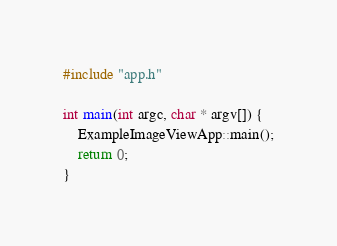Convert code to text. <code><loc_0><loc_0><loc_500><loc_500><_ObjectiveC_>#include "app.h"

int main(int argc, char * argv[]) {
	ExampleImageViewApp::main();
	return 0;
}
</code> 